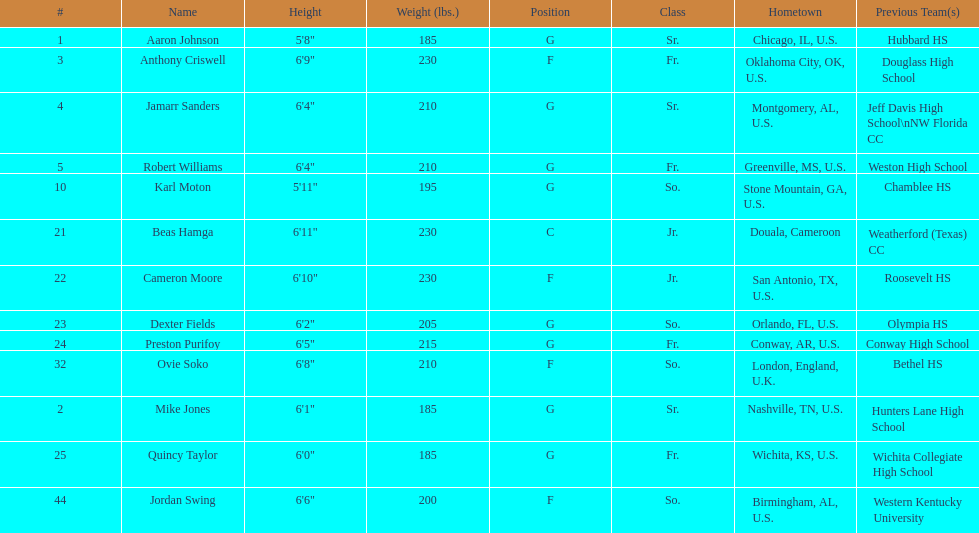What is the number of seniors on the team? 3. 